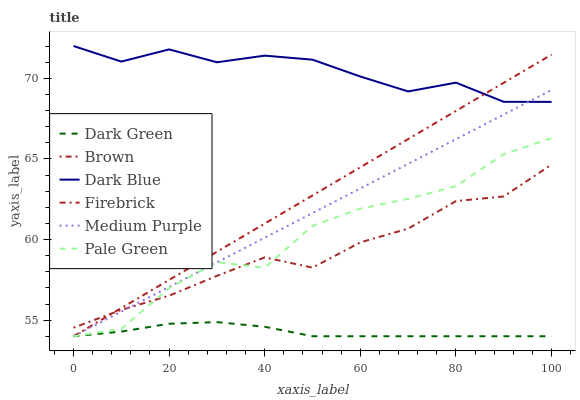Does Dark Green have the minimum area under the curve?
Answer yes or no. Yes. Does Dark Blue have the maximum area under the curve?
Answer yes or no. Yes. Does Firebrick have the minimum area under the curve?
Answer yes or no. No. Does Firebrick have the maximum area under the curve?
Answer yes or no. No. Is Medium Purple the smoothest?
Answer yes or no. Yes. Is Pale Green the roughest?
Answer yes or no. Yes. Is Firebrick the smoothest?
Answer yes or no. No. Is Firebrick the roughest?
Answer yes or no. No. Does Firebrick have the lowest value?
Answer yes or no. Yes. Does Dark Blue have the lowest value?
Answer yes or no. No. Does Dark Blue have the highest value?
Answer yes or no. Yes. Does Firebrick have the highest value?
Answer yes or no. No. Is Pale Green less than Dark Blue?
Answer yes or no. Yes. Is Dark Blue greater than Dark Green?
Answer yes or no. Yes. Does Pale Green intersect Firebrick?
Answer yes or no. Yes. Is Pale Green less than Firebrick?
Answer yes or no. No. Is Pale Green greater than Firebrick?
Answer yes or no. No. Does Pale Green intersect Dark Blue?
Answer yes or no. No. 